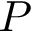Convert formula to latex. <formula><loc_0><loc_0><loc_500><loc_500>P</formula> 